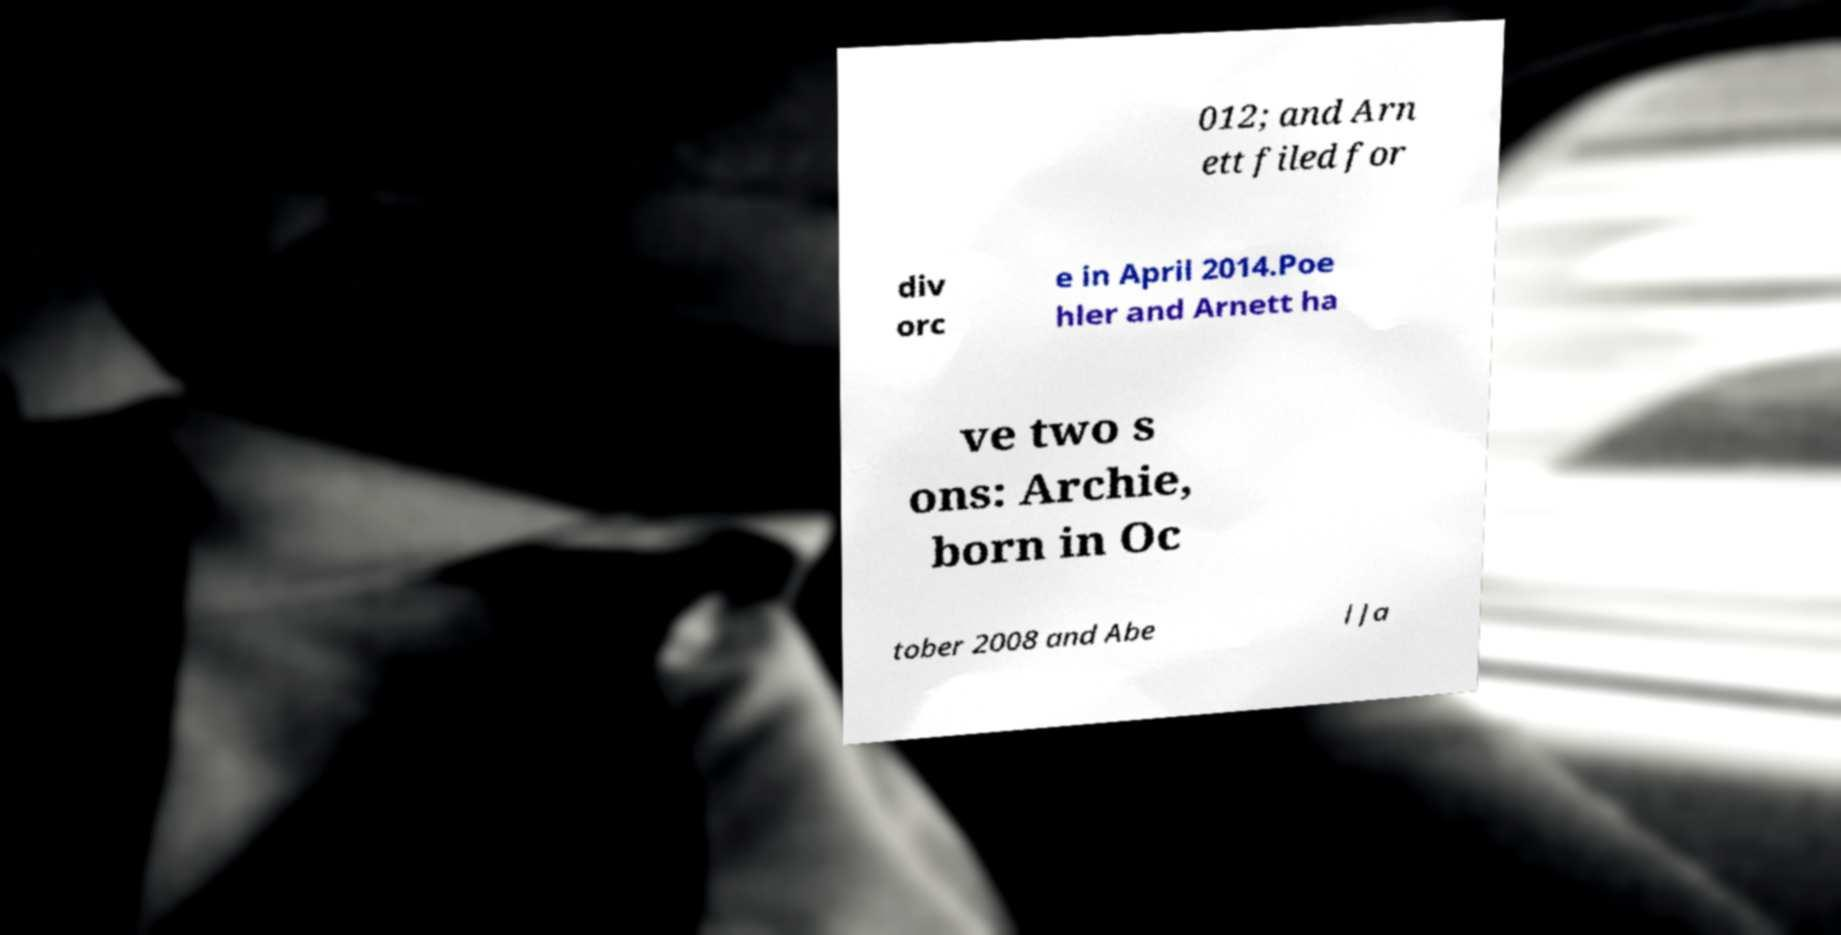Can you read and provide the text displayed in the image?This photo seems to have some interesting text. Can you extract and type it out for me? 012; and Arn ett filed for div orc e in April 2014.Poe hler and Arnett ha ve two s ons: Archie, born in Oc tober 2008 and Abe l Ja 